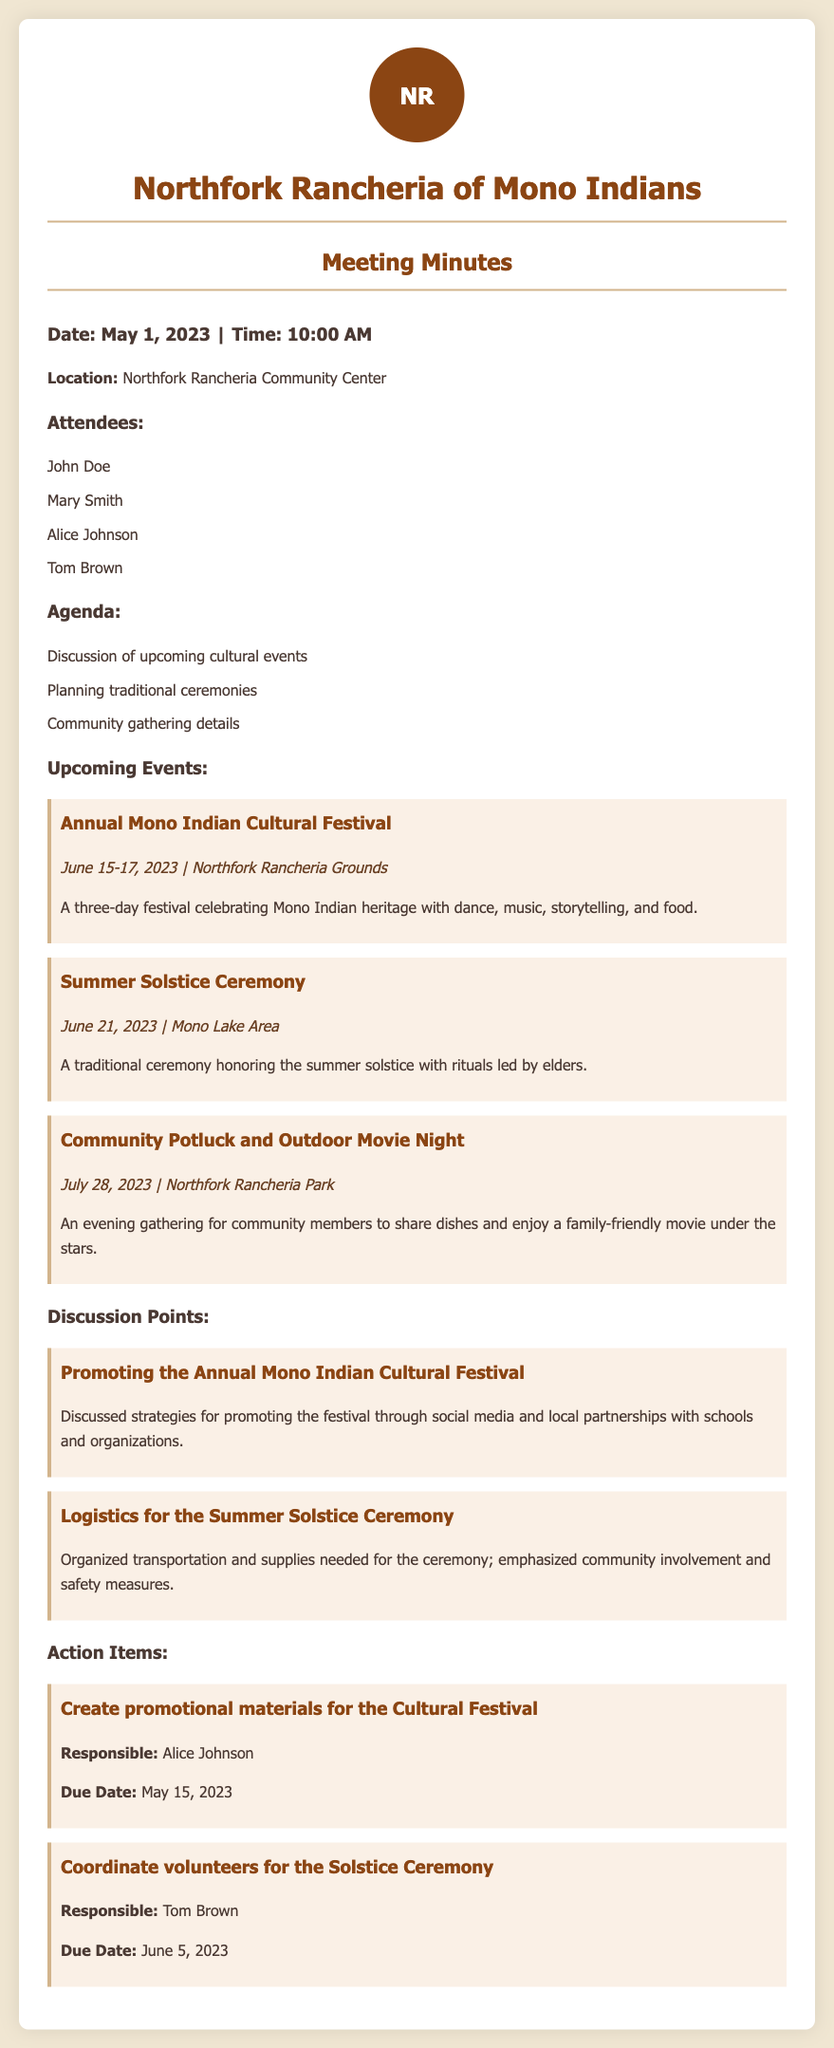What is the date of the Annual Mono Indian Cultural Festival? The date is specified in the document as June 15-17, 2023.
Answer: June 15-17, 2023 Who is responsible for creating promotional materials for the Cultural Festival? The document lists Alice Johnson as the person responsible for this action item.
Answer: Alice Johnson What is the location of the Community Potluck and Outdoor Movie Night? The document states the event will take place at the Northfork Rancheria Park.
Answer: Northfork Rancheria Park What is the due date for coordinating volunteers for the Solstice Ceremony? The document specifies June 5, 2023, as the due date for this action item.
Answer: June 5, 2023 How many attendees are listed in the meeting minutes? The document lists four attendees by name in the relevant section.
Answer: Four What key aspect was discussed regarding the promotion of the Cultural Festival? The document mentions promoting the festival through social media and local partnerships.
Answer: Social media and local partnerships What event is scheduled for June 21, 2023? The Summer Solstice Ceremony is identified as taking place on this date within the document.
Answer: Summer Solstice Ceremony What type of gathering is planned for July 28, 2023? The document describes it as a Community Potluck and Outdoor Movie Night.
Answer: Community Potluck and Outdoor Movie Night 